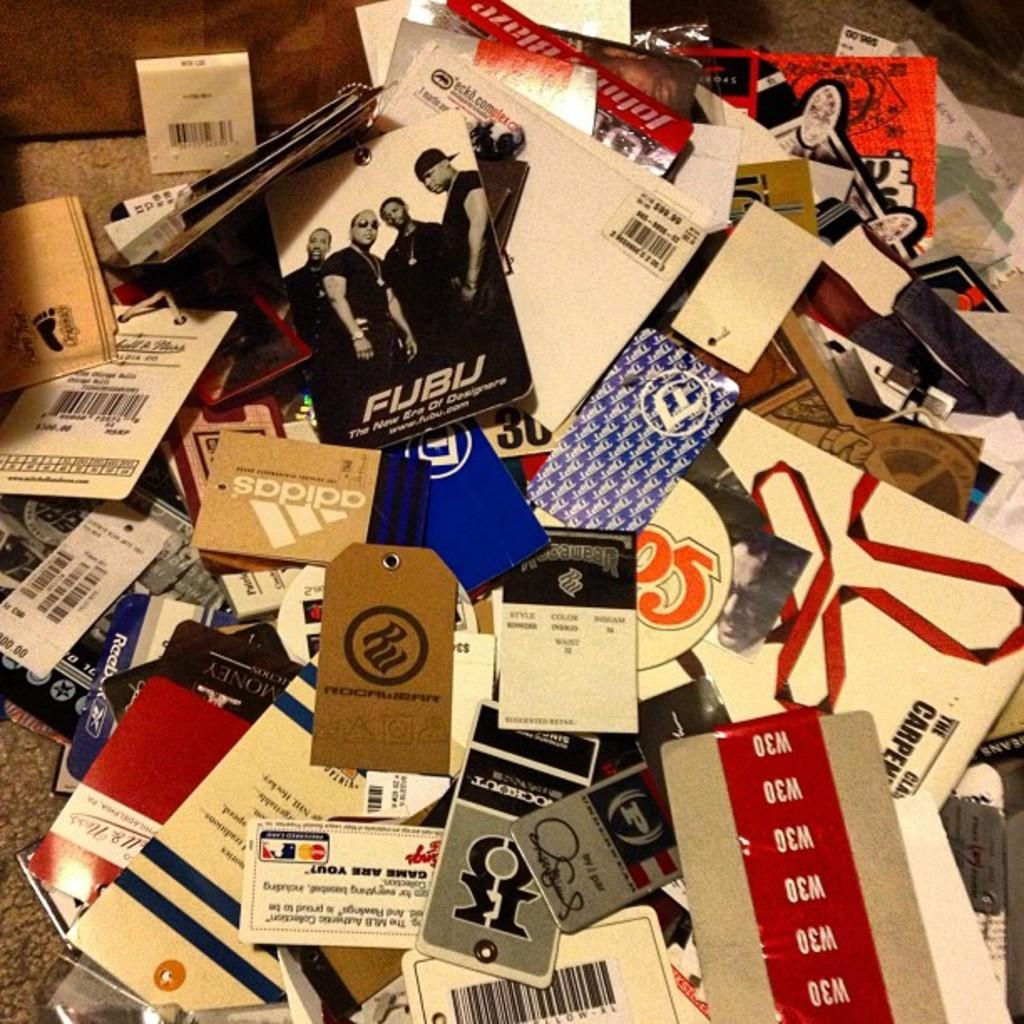What can be seen on the ground in the image? There are tags on the ground in the image. Can you describe the object at the top of the image? Unfortunately, the provided facts do not give any information about the object at the top of the image. How many toads are visible in the image? There are no toads present in the image. What type of boundary is depicted in the image? The provided facts do not mention any boundaries in the image. 